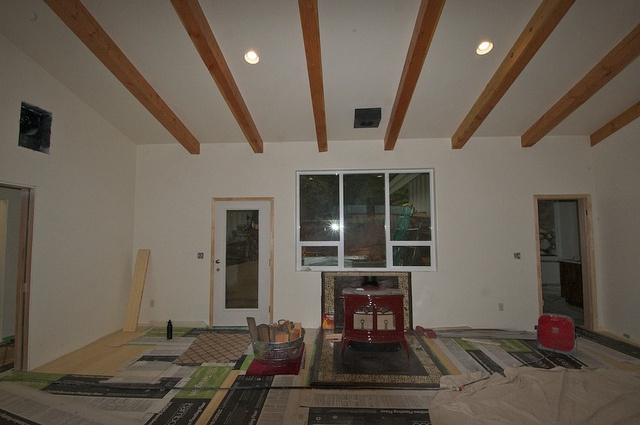Describe the objects in this image and their specific colors. I can see a bottle in black tones in this image. 